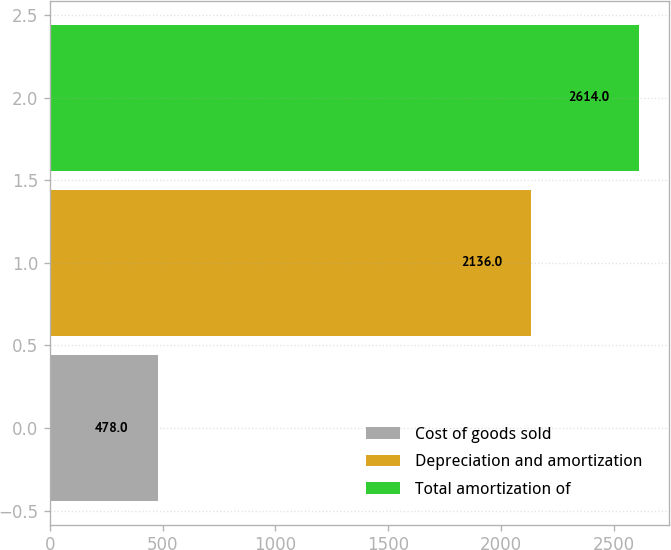Convert chart to OTSL. <chart><loc_0><loc_0><loc_500><loc_500><bar_chart><fcel>Cost of goods sold<fcel>Depreciation and amortization<fcel>Total amortization of<nl><fcel>478<fcel>2136<fcel>2614<nl></chart> 